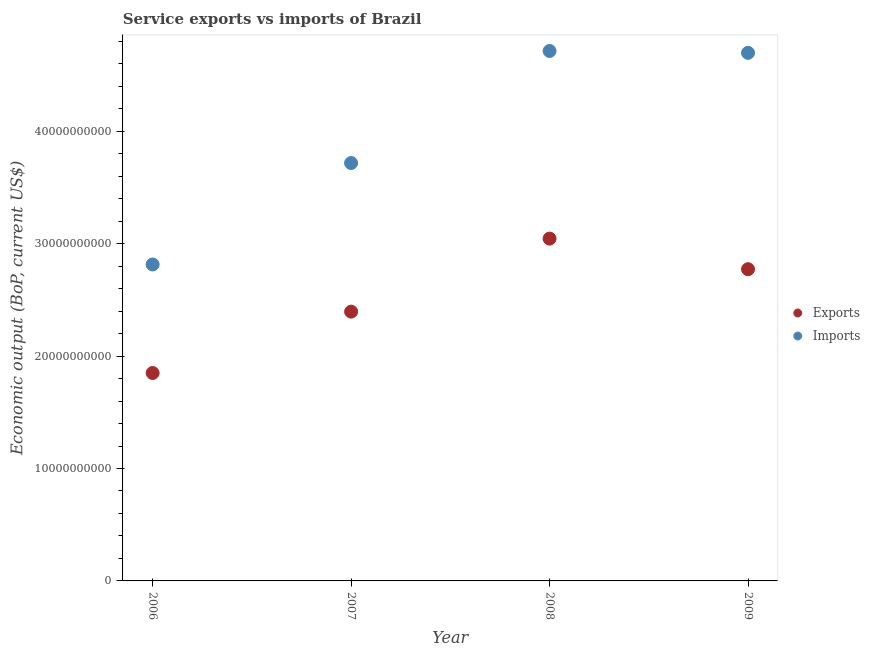How many different coloured dotlines are there?
Offer a terse response. 2. Is the number of dotlines equal to the number of legend labels?
Make the answer very short. Yes. What is the amount of service imports in 2008?
Offer a very short reply. 4.71e+1. Across all years, what is the maximum amount of service exports?
Provide a short and direct response. 3.05e+1. Across all years, what is the minimum amount of service exports?
Provide a short and direct response. 1.85e+1. What is the total amount of service exports in the graph?
Give a very brief answer. 1.01e+11. What is the difference between the amount of service imports in 2006 and that in 2007?
Your answer should be very brief. -9.02e+09. What is the difference between the amount of service imports in 2007 and the amount of service exports in 2009?
Offer a terse response. 9.44e+09. What is the average amount of service imports per year?
Your answer should be compact. 3.99e+1. In the year 2009, what is the difference between the amount of service imports and amount of service exports?
Provide a succinct answer. 1.92e+1. In how many years, is the amount of service exports greater than 36000000000 US$?
Your answer should be very brief. 0. What is the ratio of the amount of service exports in 2007 to that in 2008?
Your answer should be very brief. 0.79. Is the amount of service imports in 2007 less than that in 2009?
Ensure brevity in your answer.  Yes. What is the difference between the highest and the second highest amount of service exports?
Your response must be concise. 2.72e+09. What is the difference between the highest and the lowest amount of service imports?
Your answer should be compact. 1.90e+1. Is the sum of the amount of service imports in 2006 and 2009 greater than the maximum amount of service exports across all years?
Provide a short and direct response. Yes. Is the amount of service exports strictly less than the amount of service imports over the years?
Keep it short and to the point. Yes. Does the graph contain grids?
Make the answer very short. No. Where does the legend appear in the graph?
Make the answer very short. Center right. How many legend labels are there?
Make the answer very short. 2. How are the legend labels stacked?
Provide a short and direct response. Vertical. What is the title of the graph?
Give a very brief answer. Service exports vs imports of Brazil. Does "Rural" appear as one of the legend labels in the graph?
Keep it short and to the point. No. What is the label or title of the X-axis?
Provide a succinct answer. Year. What is the label or title of the Y-axis?
Make the answer very short. Economic output (BoP, current US$). What is the Economic output (BoP, current US$) of Exports in 2006?
Your answer should be compact. 1.85e+1. What is the Economic output (BoP, current US$) in Imports in 2006?
Make the answer very short. 2.81e+1. What is the Economic output (BoP, current US$) in Exports in 2007?
Ensure brevity in your answer.  2.40e+1. What is the Economic output (BoP, current US$) of Imports in 2007?
Provide a succinct answer. 3.72e+1. What is the Economic output (BoP, current US$) in Exports in 2008?
Your answer should be very brief. 3.05e+1. What is the Economic output (BoP, current US$) in Imports in 2008?
Your response must be concise. 4.71e+1. What is the Economic output (BoP, current US$) of Exports in 2009?
Your response must be concise. 2.77e+1. What is the Economic output (BoP, current US$) of Imports in 2009?
Offer a very short reply. 4.70e+1. Across all years, what is the maximum Economic output (BoP, current US$) of Exports?
Offer a terse response. 3.05e+1. Across all years, what is the maximum Economic output (BoP, current US$) of Imports?
Offer a very short reply. 4.71e+1. Across all years, what is the minimum Economic output (BoP, current US$) of Exports?
Offer a very short reply. 1.85e+1. Across all years, what is the minimum Economic output (BoP, current US$) of Imports?
Provide a short and direct response. 2.81e+1. What is the total Economic output (BoP, current US$) in Exports in the graph?
Offer a very short reply. 1.01e+11. What is the total Economic output (BoP, current US$) in Imports in the graph?
Offer a terse response. 1.59e+11. What is the difference between the Economic output (BoP, current US$) of Exports in 2006 and that in 2007?
Make the answer very short. -5.46e+09. What is the difference between the Economic output (BoP, current US$) in Imports in 2006 and that in 2007?
Ensure brevity in your answer.  -9.02e+09. What is the difference between the Economic output (BoP, current US$) of Exports in 2006 and that in 2008?
Offer a very short reply. -1.20e+1. What is the difference between the Economic output (BoP, current US$) in Imports in 2006 and that in 2008?
Keep it short and to the point. -1.90e+1. What is the difference between the Economic output (BoP, current US$) in Exports in 2006 and that in 2009?
Provide a short and direct response. -9.23e+09. What is the difference between the Economic output (BoP, current US$) of Imports in 2006 and that in 2009?
Your answer should be very brief. -1.88e+1. What is the difference between the Economic output (BoP, current US$) in Exports in 2007 and that in 2008?
Make the answer very short. -6.50e+09. What is the difference between the Economic output (BoP, current US$) of Imports in 2007 and that in 2008?
Provide a short and direct response. -9.97e+09. What is the difference between the Economic output (BoP, current US$) in Exports in 2007 and that in 2009?
Provide a succinct answer. -3.77e+09. What is the difference between the Economic output (BoP, current US$) in Imports in 2007 and that in 2009?
Your response must be concise. -9.80e+09. What is the difference between the Economic output (BoP, current US$) in Exports in 2008 and that in 2009?
Provide a short and direct response. 2.72e+09. What is the difference between the Economic output (BoP, current US$) in Imports in 2008 and that in 2009?
Ensure brevity in your answer.  1.66e+08. What is the difference between the Economic output (BoP, current US$) in Exports in 2006 and the Economic output (BoP, current US$) in Imports in 2007?
Offer a terse response. -1.87e+1. What is the difference between the Economic output (BoP, current US$) in Exports in 2006 and the Economic output (BoP, current US$) in Imports in 2008?
Provide a succinct answer. -2.86e+1. What is the difference between the Economic output (BoP, current US$) in Exports in 2006 and the Economic output (BoP, current US$) in Imports in 2009?
Ensure brevity in your answer.  -2.85e+1. What is the difference between the Economic output (BoP, current US$) of Exports in 2007 and the Economic output (BoP, current US$) of Imports in 2008?
Make the answer very short. -2.32e+1. What is the difference between the Economic output (BoP, current US$) in Exports in 2007 and the Economic output (BoP, current US$) in Imports in 2009?
Keep it short and to the point. -2.30e+1. What is the difference between the Economic output (BoP, current US$) in Exports in 2008 and the Economic output (BoP, current US$) in Imports in 2009?
Offer a terse response. -1.65e+1. What is the average Economic output (BoP, current US$) in Exports per year?
Offer a very short reply. 2.52e+1. What is the average Economic output (BoP, current US$) of Imports per year?
Your response must be concise. 3.99e+1. In the year 2006, what is the difference between the Economic output (BoP, current US$) of Exports and Economic output (BoP, current US$) of Imports?
Your answer should be very brief. -9.65e+09. In the year 2007, what is the difference between the Economic output (BoP, current US$) in Exports and Economic output (BoP, current US$) in Imports?
Make the answer very short. -1.32e+1. In the year 2008, what is the difference between the Economic output (BoP, current US$) of Exports and Economic output (BoP, current US$) of Imports?
Give a very brief answer. -1.67e+1. In the year 2009, what is the difference between the Economic output (BoP, current US$) in Exports and Economic output (BoP, current US$) in Imports?
Offer a very short reply. -1.92e+1. What is the ratio of the Economic output (BoP, current US$) in Exports in 2006 to that in 2007?
Offer a terse response. 0.77. What is the ratio of the Economic output (BoP, current US$) of Imports in 2006 to that in 2007?
Make the answer very short. 0.76. What is the ratio of the Economic output (BoP, current US$) of Exports in 2006 to that in 2008?
Your response must be concise. 0.61. What is the ratio of the Economic output (BoP, current US$) of Imports in 2006 to that in 2008?
Keep it short and to the point. 0.6. What is the ratio of the Economic output (BoP, current US$) of Exports in 2006 to that in 2009?
Provide a succinct answer. 0.67. What is the ratio of the Economic output (BoP, current US$) in Imports in 2006 to that in 2009?
Offer a very short reply. 0.6. What is the ratio of the Economic output (BoP, current US$) of Exports in 2007 to that in 2008?
Offer a very short reply. 0.79. What is the ratio of the Economic output (BoP, current US$) of Imports in 2007 to that in 2008?
Give a very brief answer. 0.79. What is the ratio of the Economic output (BoP, current US$) of Exports in 2007 to that in 2009?
Make the answer very short. 0.86. What is the ratio of the Economic output (BoP, current US$) in Imports in 2007 to that in 2009?
Offer a terse response. 0.79. What is the ratio of the Economic output (BoP, current US$) in Exports in 2008 to that in 2009?
Offer a terse response. 1.1. What is the difference between the highest and the second highest Economic output (BoP, current US$) of Exports?
Make the answer very short. 2.72e+09. What is the difference between the highest and the second highest Economic output (BoP, current US$) in Imports?
Ensure brevity in your answer.  1.66e+08. What is the difference between the highest and the lowest Economic output (BoP, current US$) in Exports?
Your answer should be compact. 1.20e+1. What is the difference between the highest and the lowest Economic output (BoP, current US$) of Imports?
Give a very brief answer. 1.90e+1. 